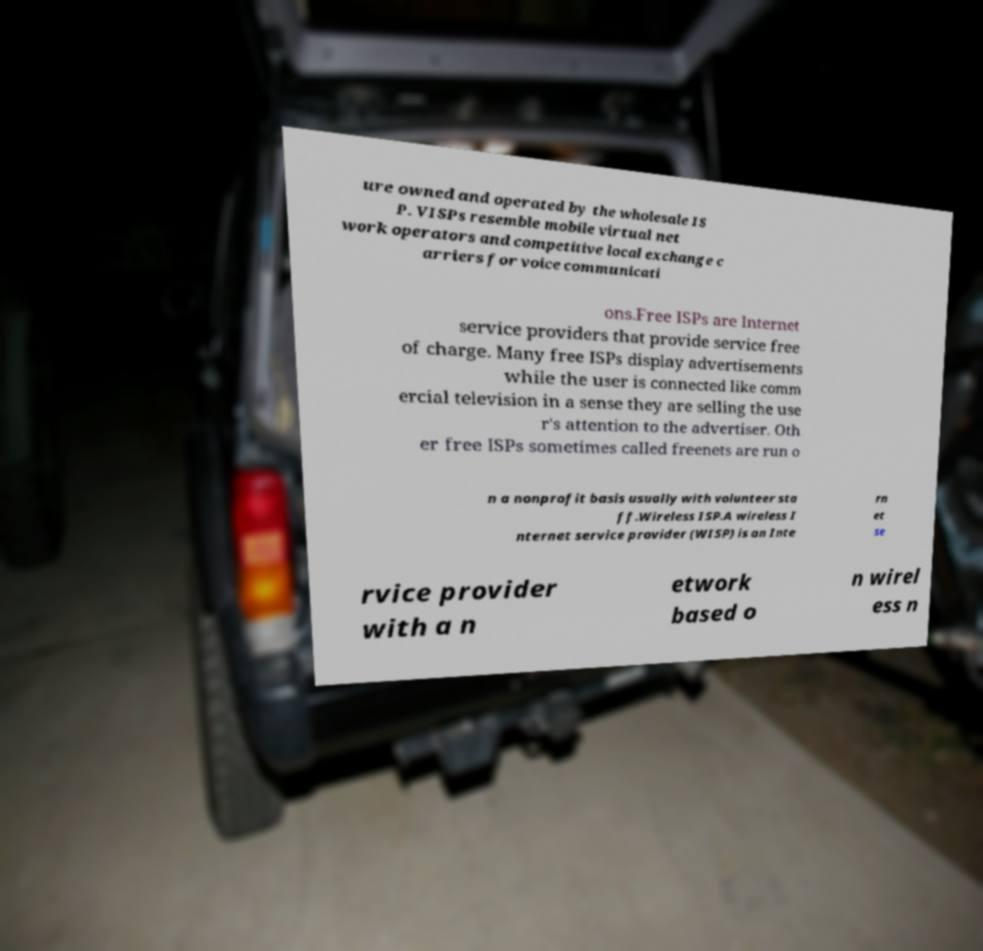Could you assist in decoding the text presented in this image and type it out clearly? ure owned and operated by the wholesale IS P. VISPs resemble mobile virtual net work operators and competitive local exchange c arriers for voice communicati ons.Free ISPs are Internet service providers that provide service free of charge. Many free ISPs display advertisements while the user is connected like comm ercial television in a sense they are selling the use r's attention to the advertiser. Oth er free ISPs sometimes called freenets are run o n a nonprofit basis usually with volunteer sta ff.Wireless ISP.A wireless I nternet service provider (WISP) is an Inte rn et se rvice provider with a n etwork based o n wirel ess n 